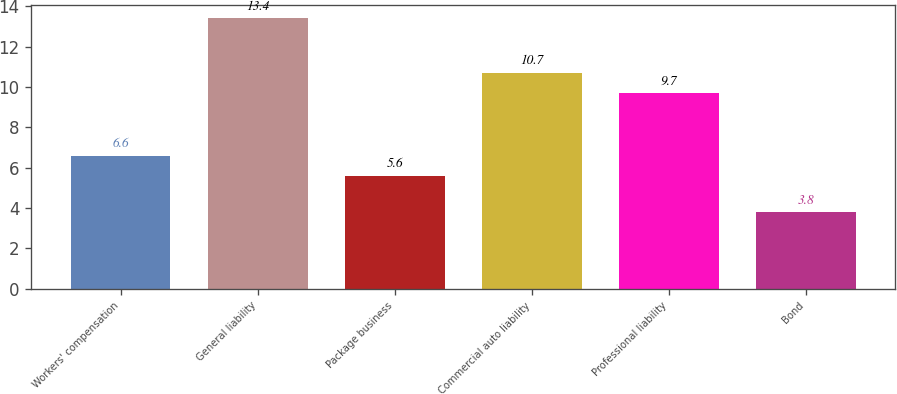Convert chart. <chart><loc_0><loc_0><loc_500><loc_500><bar_chart><fcel>Workers' compensation<fcel>General liability<fcel>Package business<fcel>Commercial auto liability<fcel>Professional liability<fcel>Bond<nl><fcel>6.6<fcel>13.4<fcel>5.6<fcel>10.7<fcel>9.7<fcel>3.8<nl></chart> 